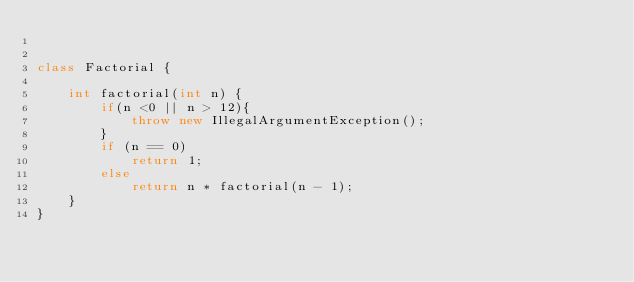<code> <loc_0><loc_0><loc_500><loc_500><_Java_>

class Factorial {

    int factorial(int n) {
        if(n <0 || n > 12){
            throw new IllegalArgumentException();
        }
        if (n == 0)
            return 1;
        else
            return n * factorial(n - 1);
    }
}</code> 